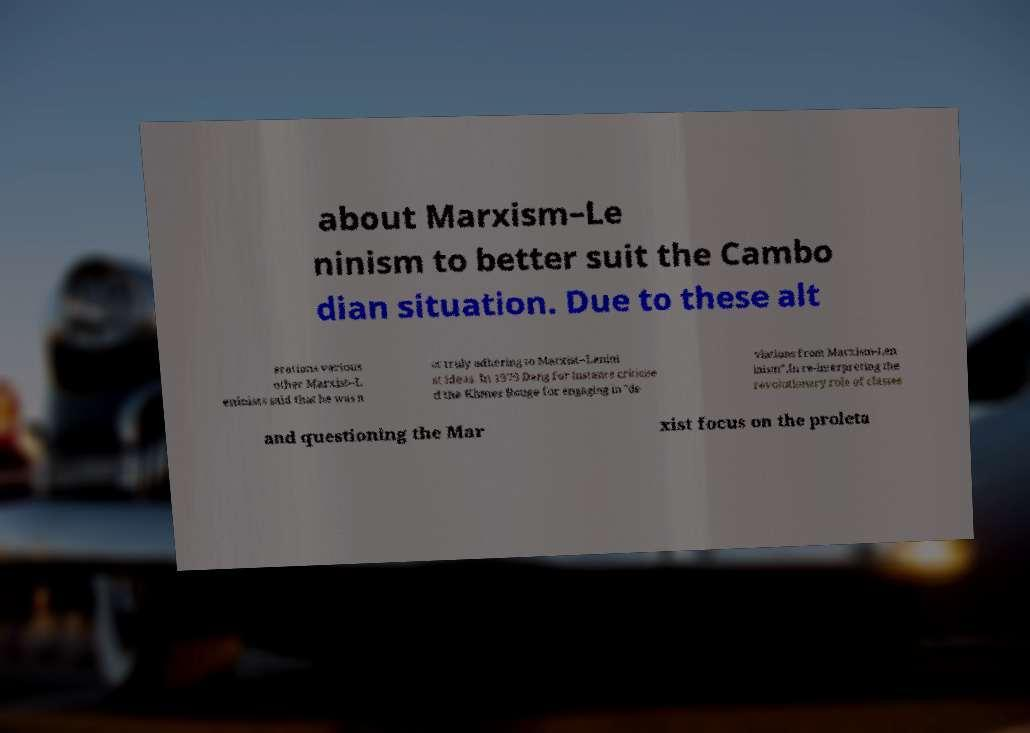Please identify and transcribe the text found in this image. about Marxism–Le ninism to better suit the Cambo dian situation. Due to these alt erations various other Marxist–L eninists said that he was n ot truly adhering to Marxist–Lenini st ideas. In 1979 Deng for instance criticise d the Khmer Rouge for engaging in "de viations from Marxism-Len inism".In re-interpreting the revolutionary role of classes and questioning the Mar xist focus on the proleta 